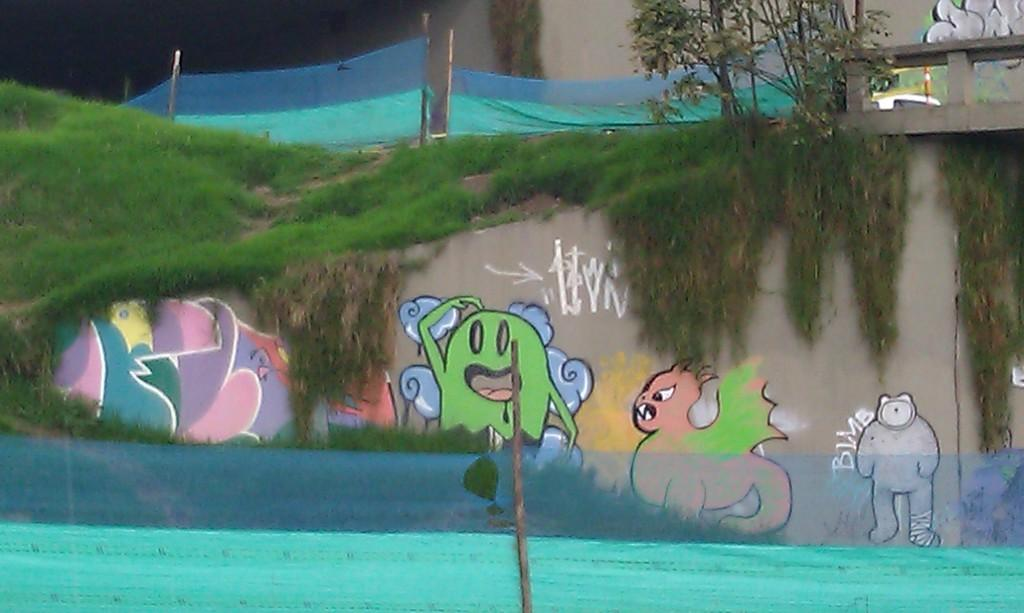What is hanging on the wall in the image? There is a painting on the wall in the image. What object can be seen in the image that is made of wood? There is a wooden stick in the image. What type of natural environment is visible in the image? There is grass visible in the image. What is the fence in the image made of, and what is attached to it? The fence in the image is made of cloth. What type of plant is present in the image? There is a tree in the image. What type of vegetable is growing in the hole in the image? There is no vegetable growing in a hole in the image; the facts provided do not mention any holes. What emotion is being expressed by the tree in the image? Trees do not express emotions, so it is not possible to answer this question based on the image. 